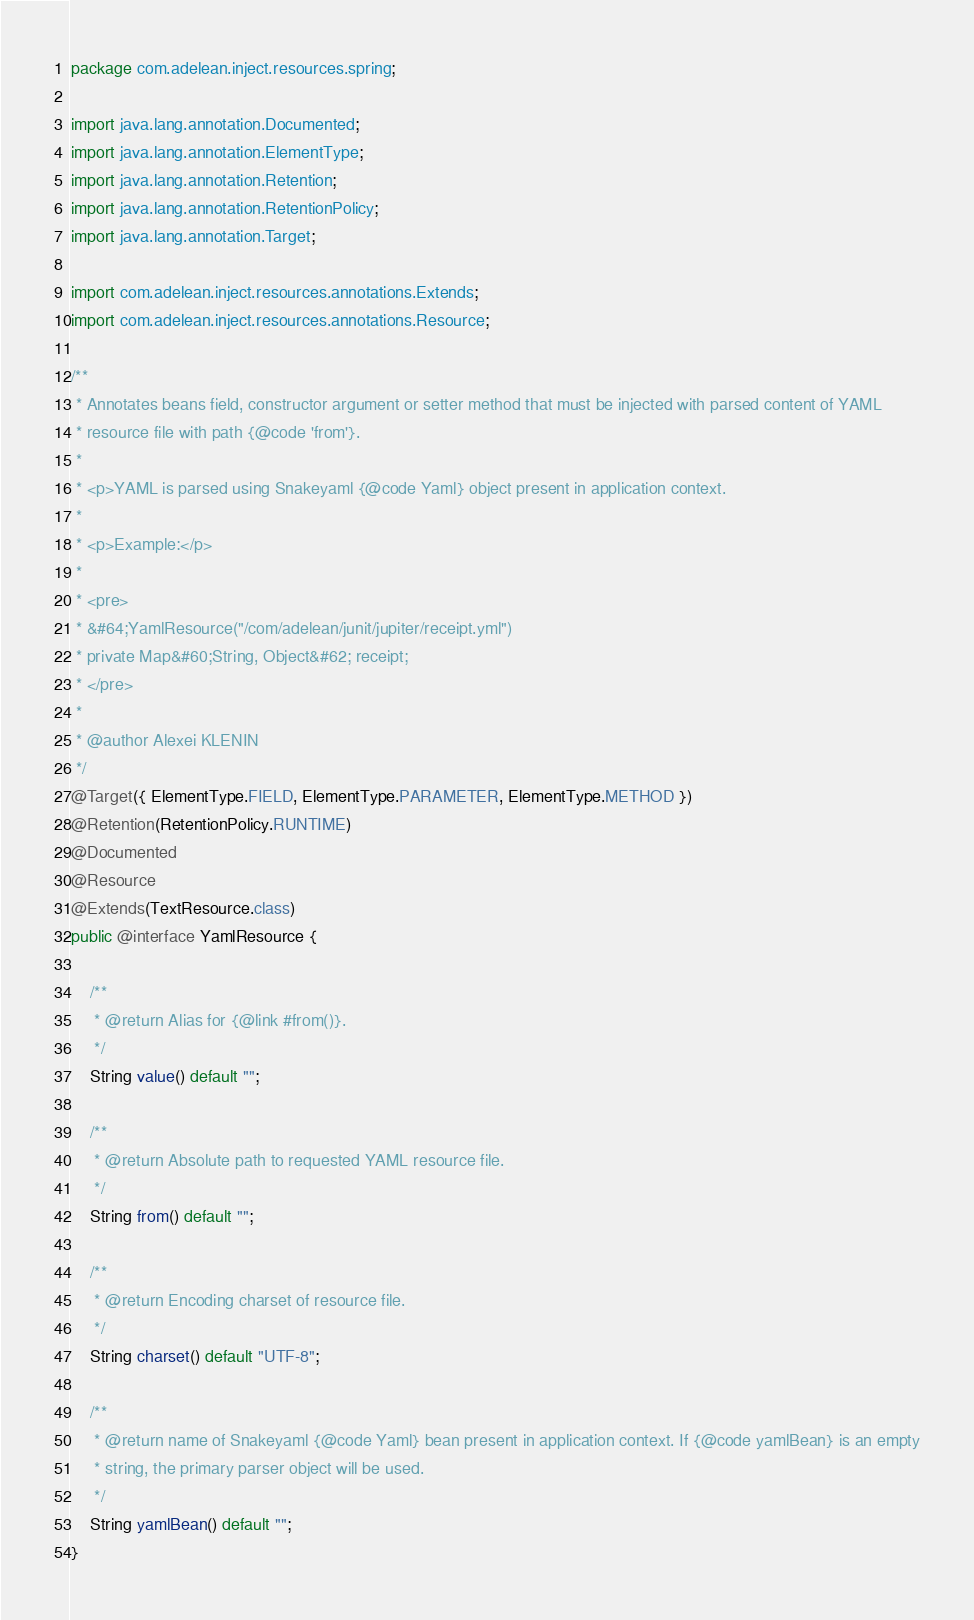<code> <loc_0><loc_0><loc_500><loc_500><_Java_>package com.adelean.inject.resources.spring;

import java.lang.annotation.Documented;
import java.lang.annotation.ElementType;
import java.lang.annotation.Retention;
import java.lang.annotation.RetentionPolicy;
import java.lang.annotation.Target;

import com.adelean.inject.resources.annotations.Extends;
import com.adelean.inject.resources.annotations.Resource;

/**
 * Annotates beans field, constructor argument or setter method that must be injected with parsed content of YAML
 * resource file with path {@code 'from'}.
 *
 * <p>YAML is parsed using Snakeyaml {@code Yaml} object present in application context.
 *
 * <p>Example:</p>
 *
 * <pre>
 * &#64;YamlResource("/com/adelean/junit/jupiter/receipt.yml")
 * private Map&#60;String, Object&#62; receipt;
 * </pre>
 *
 * @author Alexei KLENIN
 */
@Target({ ElementType.FIELD, ElementType.PARAMETER, ElementType.METHOD })
@Retention(RetentionPolicy.RUNTIME)
@Documented
@Resource
@Extends(TextResource.class)
public @interface YamlResource {

    /**
     * @return Alias for {@link #from()}.
     */
    String value() default "";

    /**
     * @return Absolute path to requested YAML resource file.
     */
    String from() default "";

    /**
     * @return Encoding charset of resource file.
     */
    String charset() default "UTF-8";

    /**
     * @return name of Snakeyaml {@code Yaml} bean present in application context. If {@code yamlBean} is an empty
     * string, the primary parser object will be used.
     */
    String yamlBean() default "";
}
</code> 